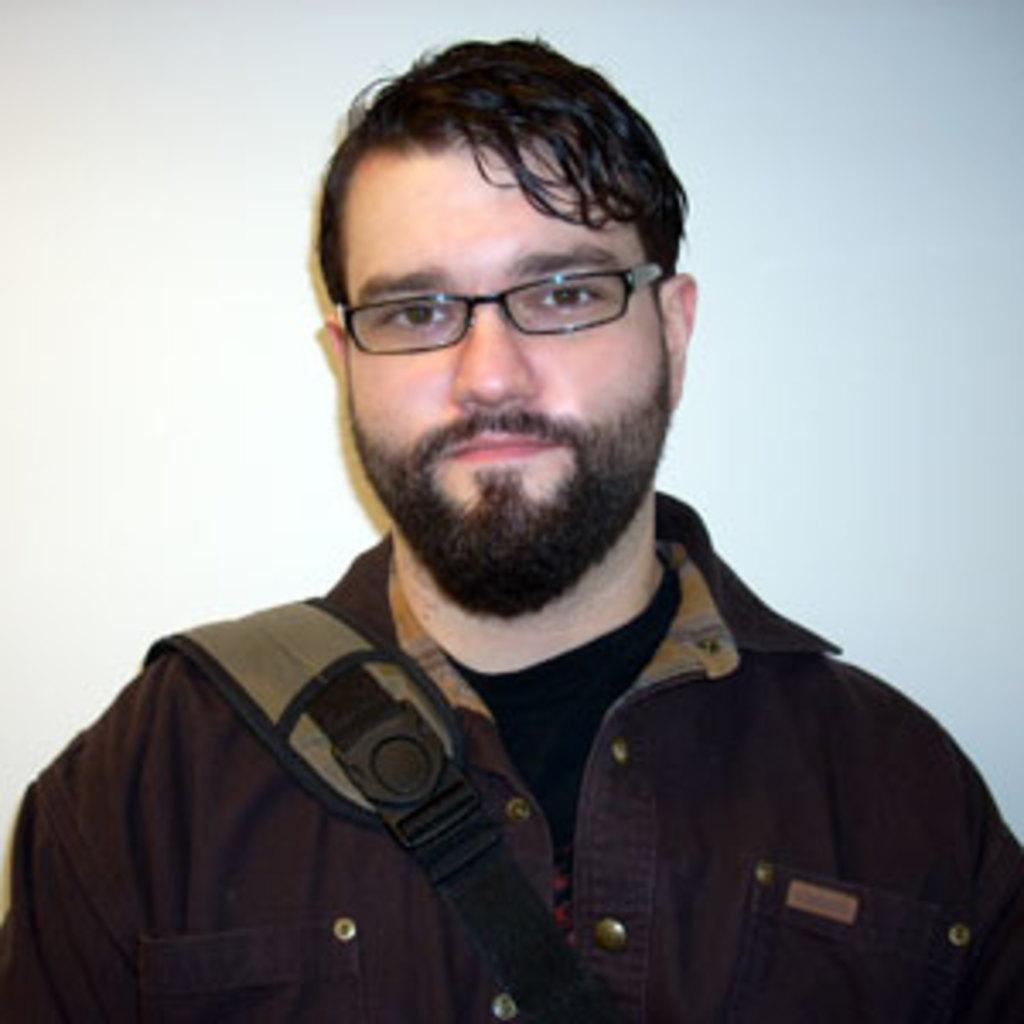What is present in the image? There is a man in the image. Can you describe the man's appearance? The man is wearing spectacles. How many cakes are being represented by the man in the image? There are no cakes present in the image, nor is the man representing any cakes. What type of sand can be seen in the image? There is no sand present in the image. 